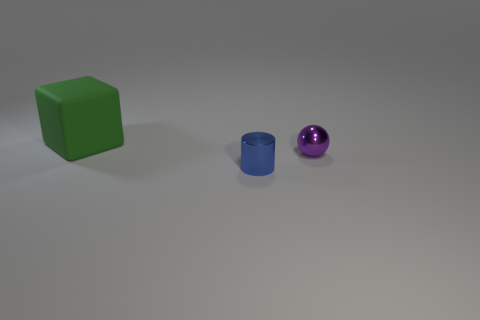What number of other objects are the same shape as the green rubber thing?
Provide a succinct answer. 0. How many brown things are either objects or matte spheres?
Offer a very short reply. 0. What color is the cylinder that is the same material as the small purple thing?
Ensure brevity in your answer.  Blue. Do the thing to the right of the tiny metallic cylinder and the thing in front of the ball have the same material?
Your answer should be very brief. Yes. What is the material of the small object on the left side of the small purple shiny ball?
Offer a terse response. Metal. Do the small object that is on the left side of the metallic ball and the thing that is behind the purple shiny object have the same shape?
Provide a succinct answer. No. Are any tiny brown rubber blocks visible?
Offer a terse response. No. Are there any green matte cubes to the left of the big green matte cube?
Give a very brief answer. No. Does the thing on the left side of the cylinder have the same material as the blue thing?
Your response must be concise. No. Are there any small metal objects that have the same color as the large thing?
Your answer should be compact. No. 